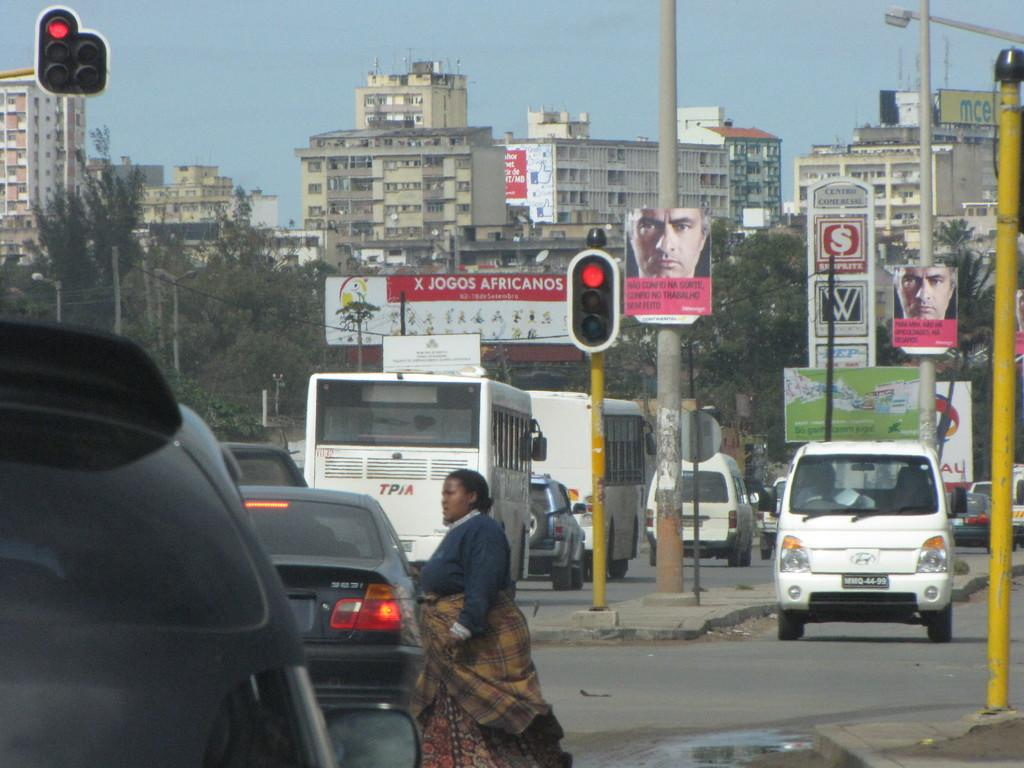What is the woman in the image doing? The woman is walking in the image. What can be seen on the road in the image? There are vehicles on the road. What helps regulate traffic in the image? There are traffic signals in the image. What type of illumination is present in the image? There are lights in the image. What are the boards on poles used for in the image? The boards on poles are likely used for advertising or displaying information. What can be seen in the background of the image? There are trees, buildings, and the sky visible in the background of the image. What type of canvas is the woman carrying in the image? There is no canvas present in the image; the woman is simply walking. 